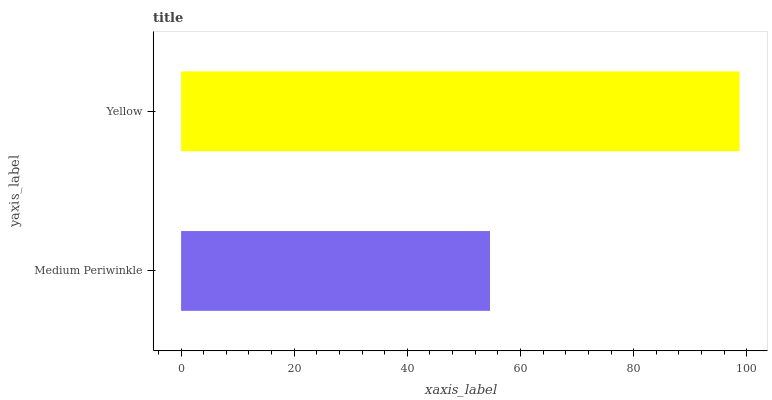Is Medium Periwinkle the minimum?
Answer yes or no. Yes. Is Yellow the maximum?
Answer yes or no. Yes. Is Yellow the minimum?
Answer yes or no. No. Is Yellow greater than Medium Periwinkle?
Answer yes or no. Yes. Is Medium Periwinkle less than Yellow?
Answer yes or no. Yes. Is Medium Periwinkle greater than Yellow?
Answer yes or no. No. Is Yellow less than Medium Periwinkle?
Answer yes or no. No. Is Yellow the high median?
Answer yes or no. Yes. Is Medium Periwinkle the low median?
Answer yes or no. Yes. Is Medium Periwinkle the high median?
Answer yes or no. No. Is Yellow the low median?
Answer yes or no. No. 